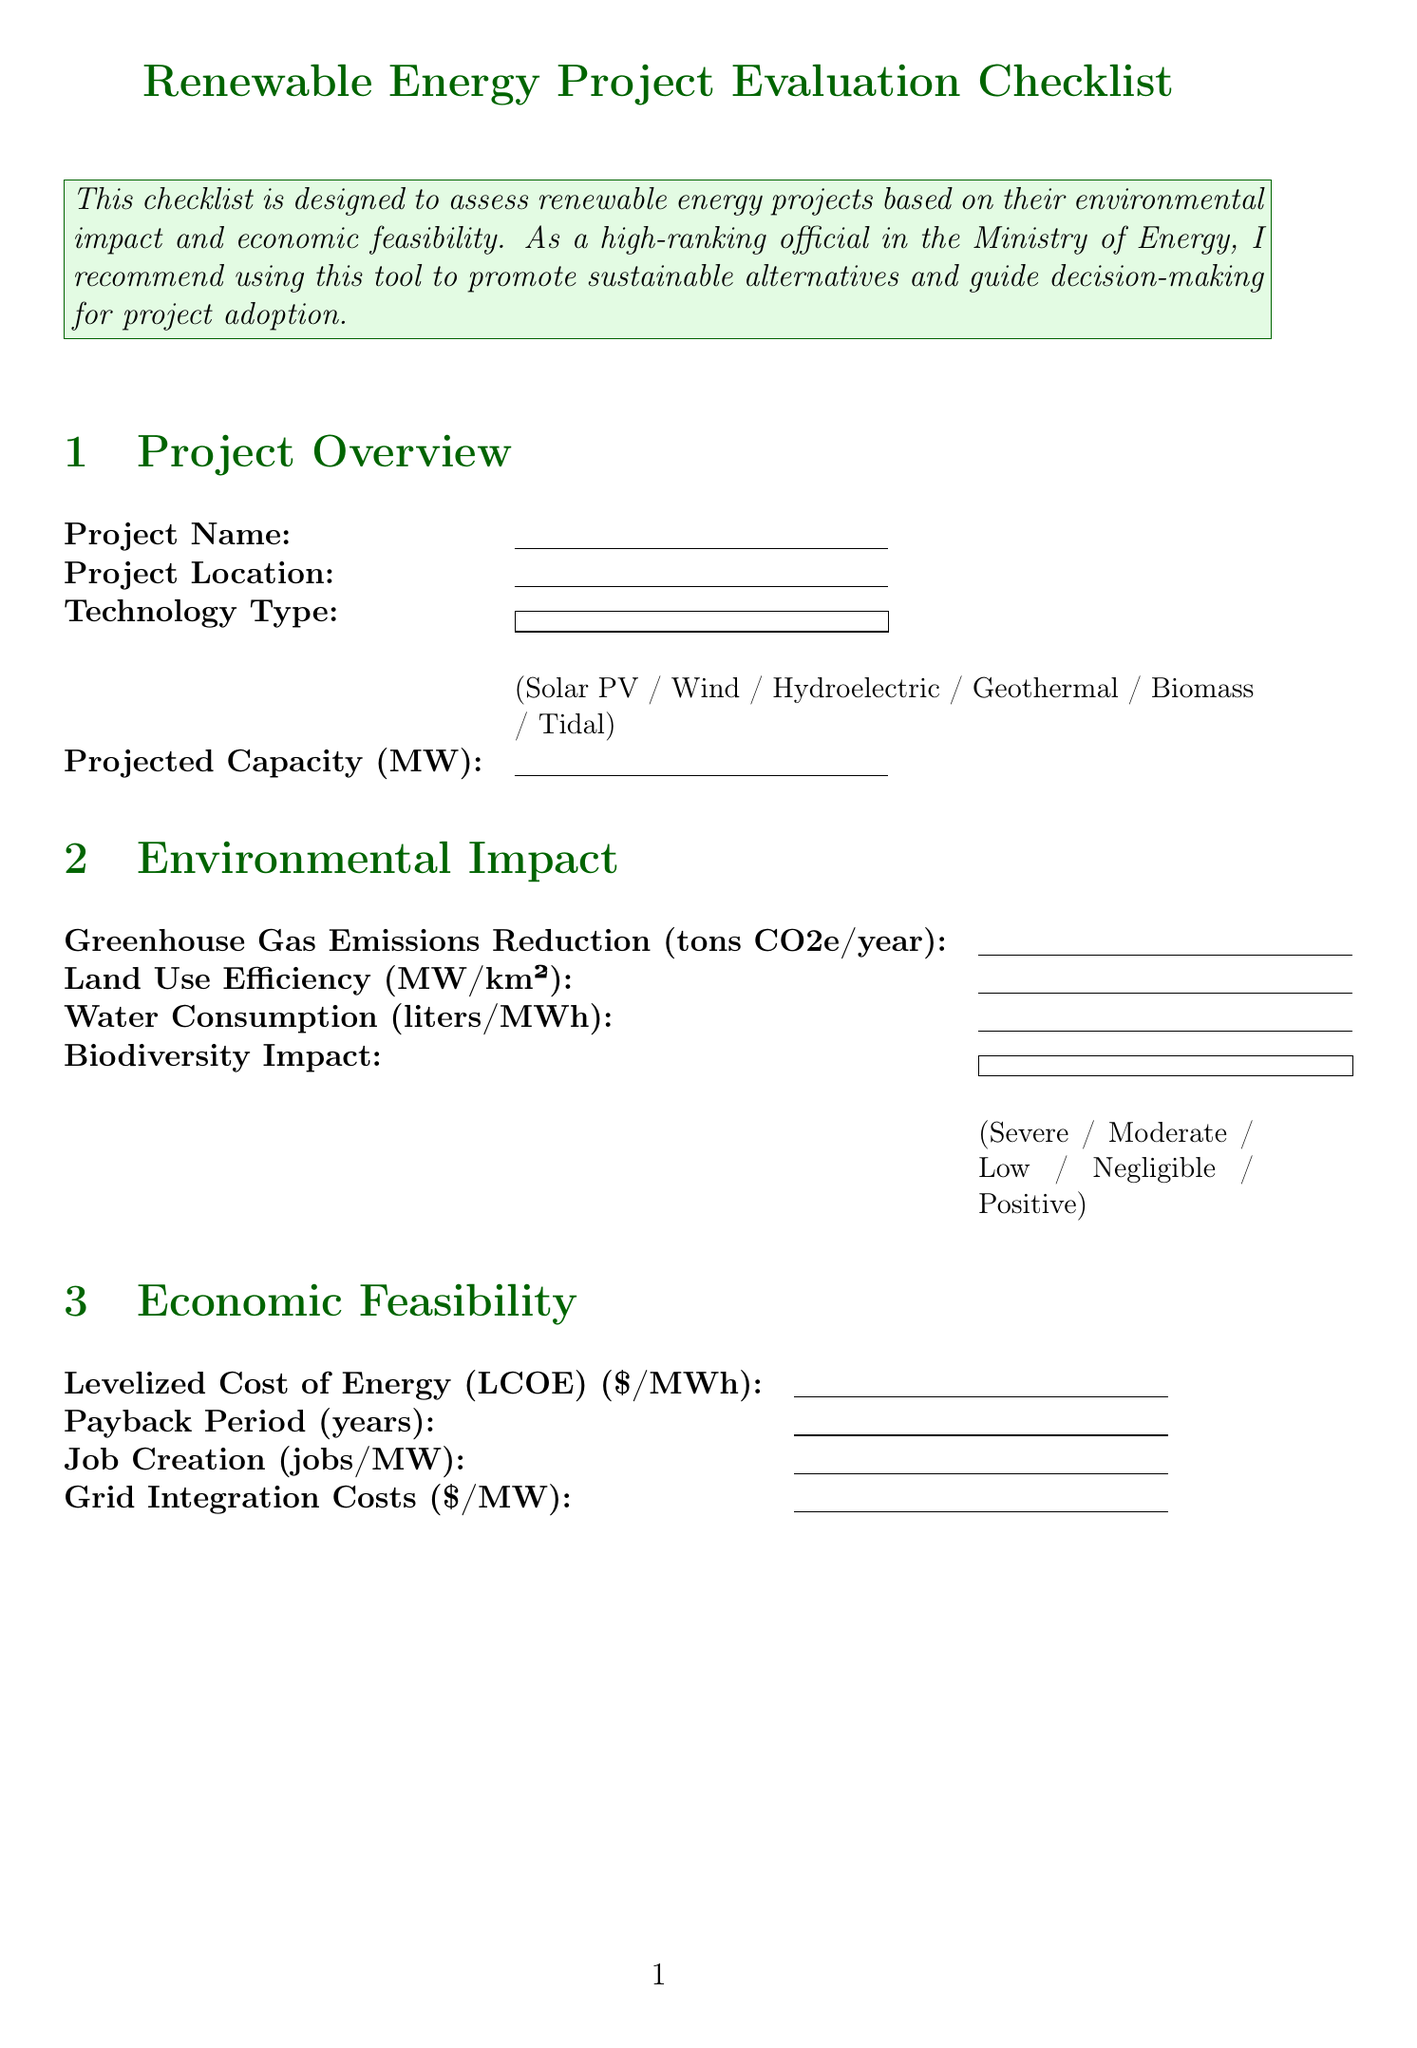What is the title of the form? The title of the form is presented at the top of the document.
Answer: Renewable Energy Project Evaluation Checklist What is the maximum score to recommend a project for adoption? The document specifies the total score needed for recommendation in the scoring instructions section.
Answer: 70 Which section contains information on job creation? The section where job creation is mentioned is related to economic aspects, as per the section headings.
Answer: Economic Feasibility What technology types are listed in the Project Overview? The available technology types for selection are stated in the dropdown of the Project Overview section.
Answer: Solar PV, Wind, Hydroelectric, Geothermal, Biomass, Tidal What is the scoring range for Greenhouse Gas Emissions Reduction? The scoring criteria for this field detail the ranges for scoring, found in the Environmental Impact section.
Answer: 0-50000 What option indicates minimal alignment with the National Energy Strategy? The options related to policy alignment are presented in a dropdown list, allowing for the identification of the least aligned choice.
Answer: Not Aligned How many scoring criteria are there for Water Consumption? The number of scoring criteria for water consumption is indicated in the Environmental Impact section.
Answer: 4 What is the significance of a project scoring 70 or higher? The scoring instructions clarify the implications of reaching this score, highlighting its importance for promotion.
Answer: Recommended for adoption What does TRL stand for in the Technology Readiness section? The document uses this acronym in the dropdown for technology readiness level, which is explained within the key terms of the section.
Answer: Technology Readiness Level 